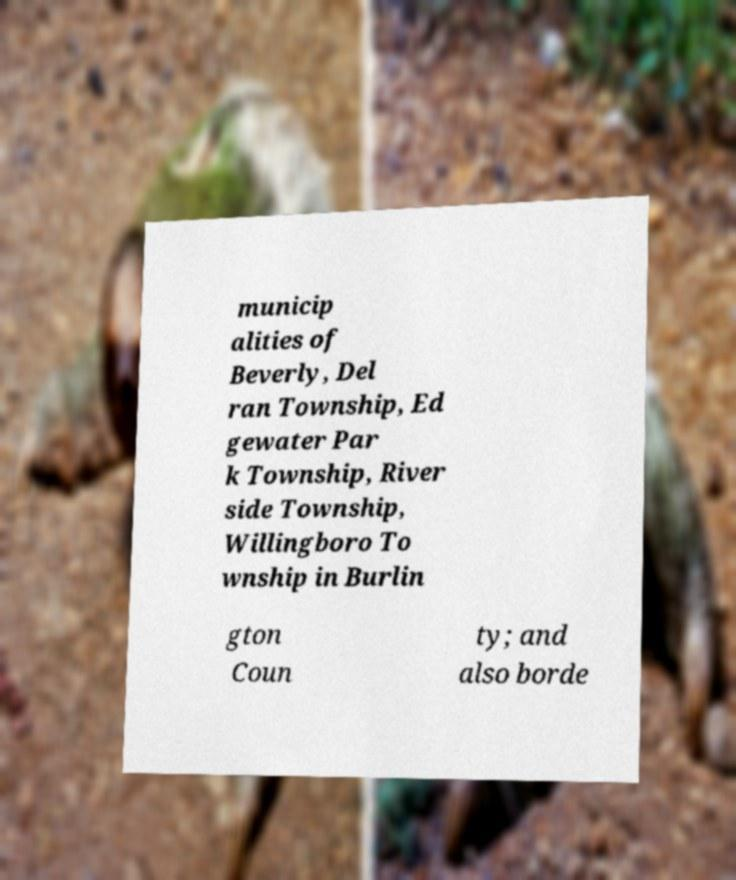I need the written content from this picture converted into text. Can you do that? municip alities of Beverly, Del ran Township, Ed gewater Par k Township, River side Township, Willingboro To wnship in Burlin gton Coun ty; and also borde 